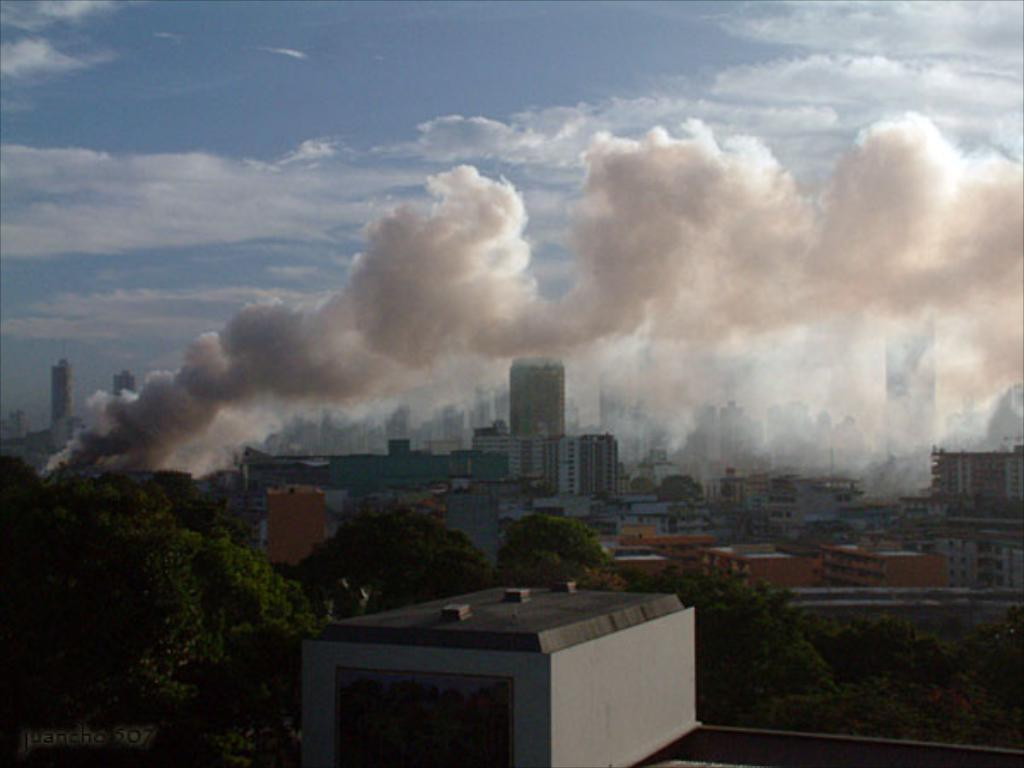What type of structures can be seen in the image? There are buildings in the image. What other natural elements are present in the image? There are trees in the image. Can you describe any visible signs of activity in the image? There is smoke visible in the image. What is visible in the background of the image? The sky is visible in the image, and clouds are present in the sky. How many kites can be seen flying in the image? There are no kites visible in the image. What type of territory is depicted in the image? The image does not depict a specific territory; it shows buildings, trees, smoke, sky, and clouds. 